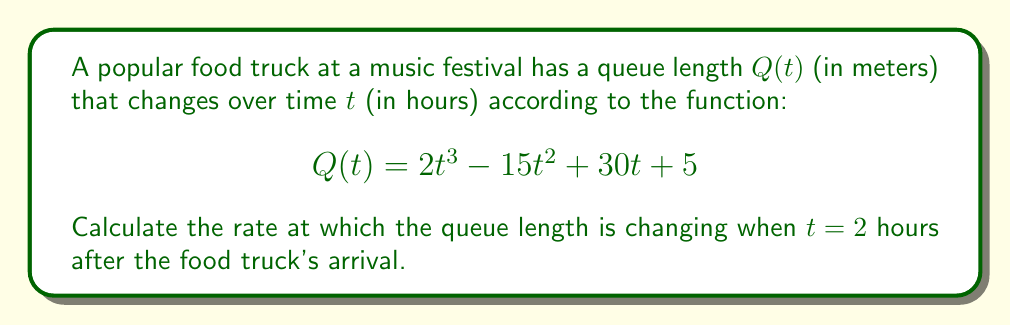Can you answer this question? To find the rate of change of the queue length at a specific time, we need to calculate the derivative of $Q(t)$ and evaluate it at $t = 2$.

Step 1: Calculate the derivative of $Q(t)$
$$\frac{d}{dt}Q(t) = \frac{d}{dt}(2t^3 - 15t^2 + 30t + 5)$$
$$Q'(t) = 6t^2 - 30t + 30$$

Step 2: Evaluate $Q'(t)$ at $t = 2$
$$Q'(2) = 6(2)^2 - 30(2) + 30$$
$$Q'(2) = 6(4) - 60 + 30$$
$$Q'(2) = 24 - 60 + 30$$
$$Q'(2) = -6$$

The negative value indicates that the queue length is decreasing at $t = 2$ hours.
Answer: $-6$ meters per hour 